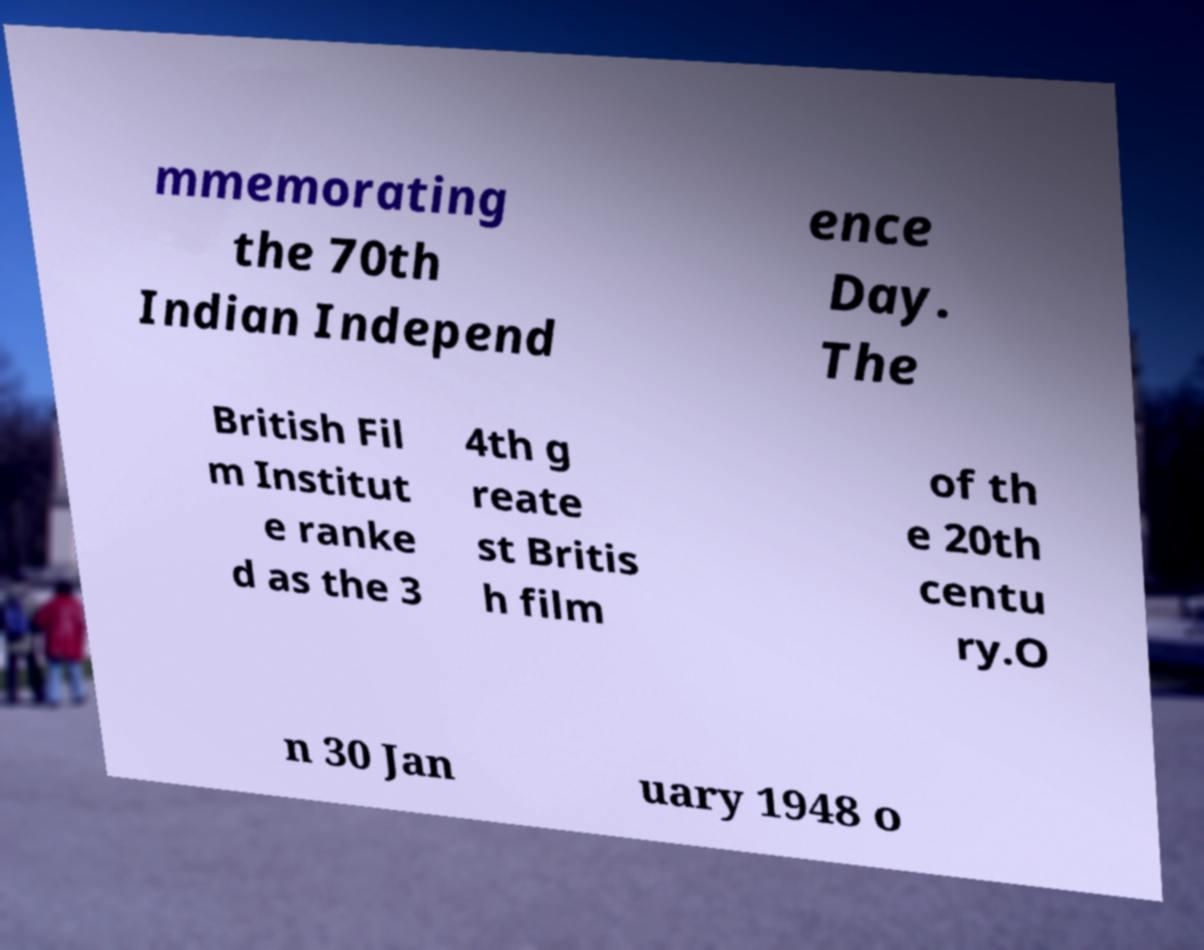For documentation purposes, I need the text within this image transcribed. Could you provide that? mmemorating the 70th Indian Independ ence Day. The British Fil m Institut e ranke d as the 3 4th g reate st Britis h film of th e 20th centu ry.O n 30 Jan uary 1948 o 